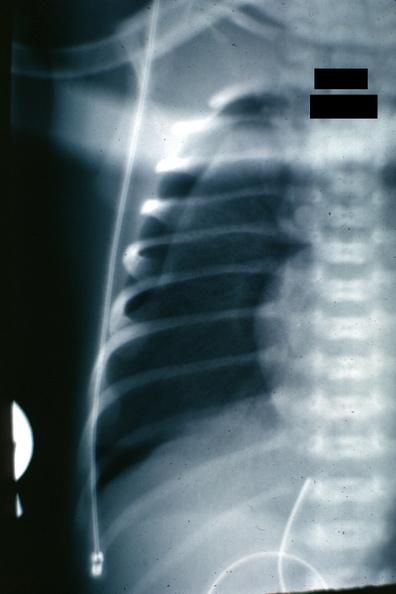what is present?
Answer the question using a single word or phrase. Pneumothorax x-ray infant 